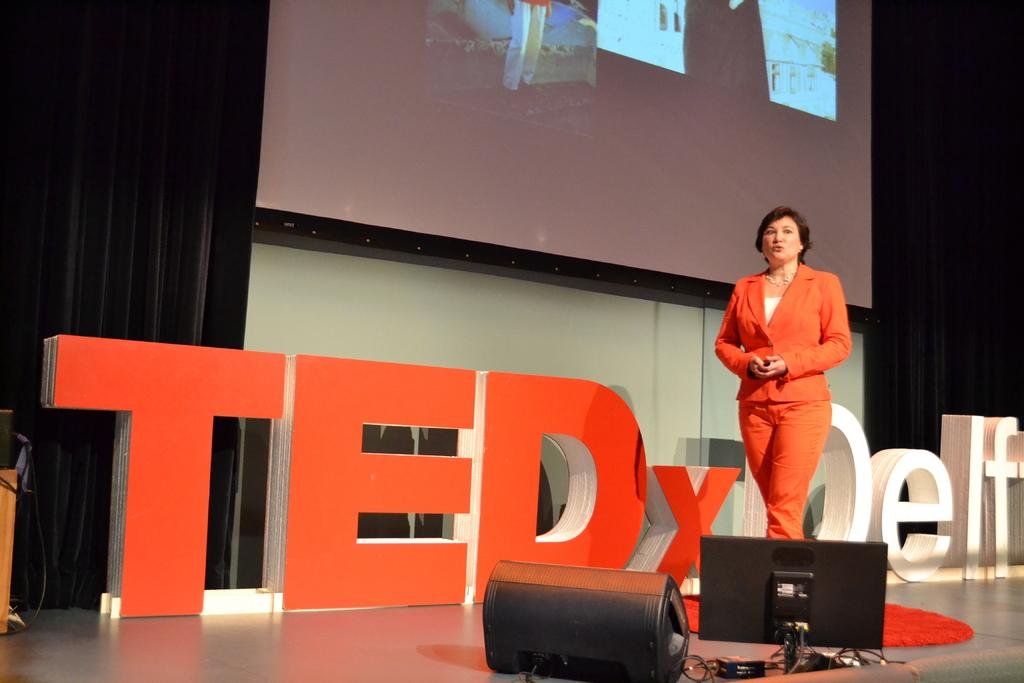Who is present in the image? There is a woman in the image. What is the woman doing in the image? The woman is walking. What can be seen in the background of the image? There is a screen and a black curtain in the backdrop. What type of dress is the woman wearing in the scene? The image does not show the woman wearing a dress, and there is no scene mentioned in the facts. 